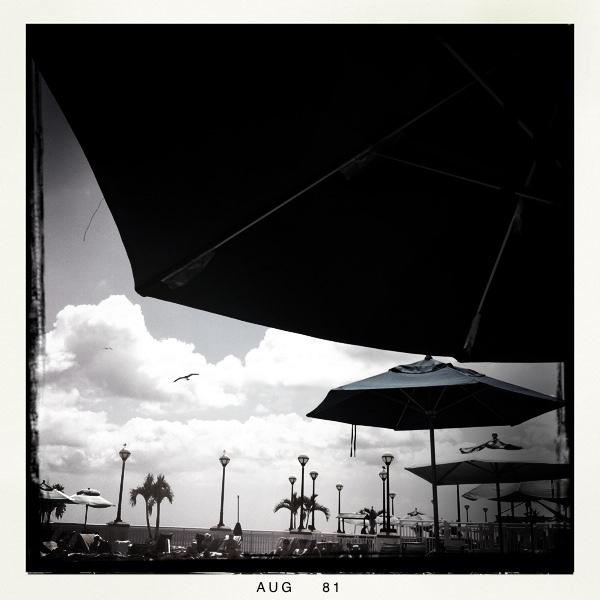Is this inside?
Be succinct. No. How many birds do you see in the air?
Give a very brief answer. 1. What color is the photo?
Keep it brief. Black and white. Was this photo taken at night?
Keep it brief. No. 